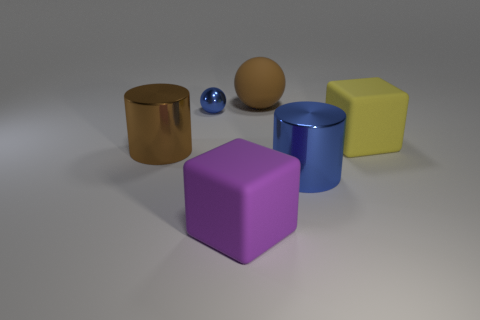What is the tiny blue sphere made of?
Your answer should be very brief. Metal. What number of objects are either metal spheres or blue cylinders?
Ensure brevity in your answer.  2. Does the brown thing right of the big purple matte object have the same size as the blue object behind the brown metallic object?
Provide a short and direct response. No. How many other things are there of the same size as the metallic ball?
Your answer should be very brief. 0. What number of things are metal balls behind the blue metal cylinder or matte things in front of the small object?
Your answer should be very brief. 3. Is the material of the big brown cylinder the same as the cylinder on the right side of the big purple cube?
Offer a very short reply. Yes. How many other things are the same shape as the large blue thing?
Provide a succinct answer. 1. The big brown thing that is in front of the big block that is to the right of the sphere right of the purple cube is made of what material?
Provide a short and direct response. Metal. Are there an equal number of small things that are behind the brown ball and red metal cubes?
Provide a short and direct response. Yes. Do the large block that is behind the brown metallic cylinder and the blue object to the left of the big purple object have the same material?
Offer a terse response. No. 